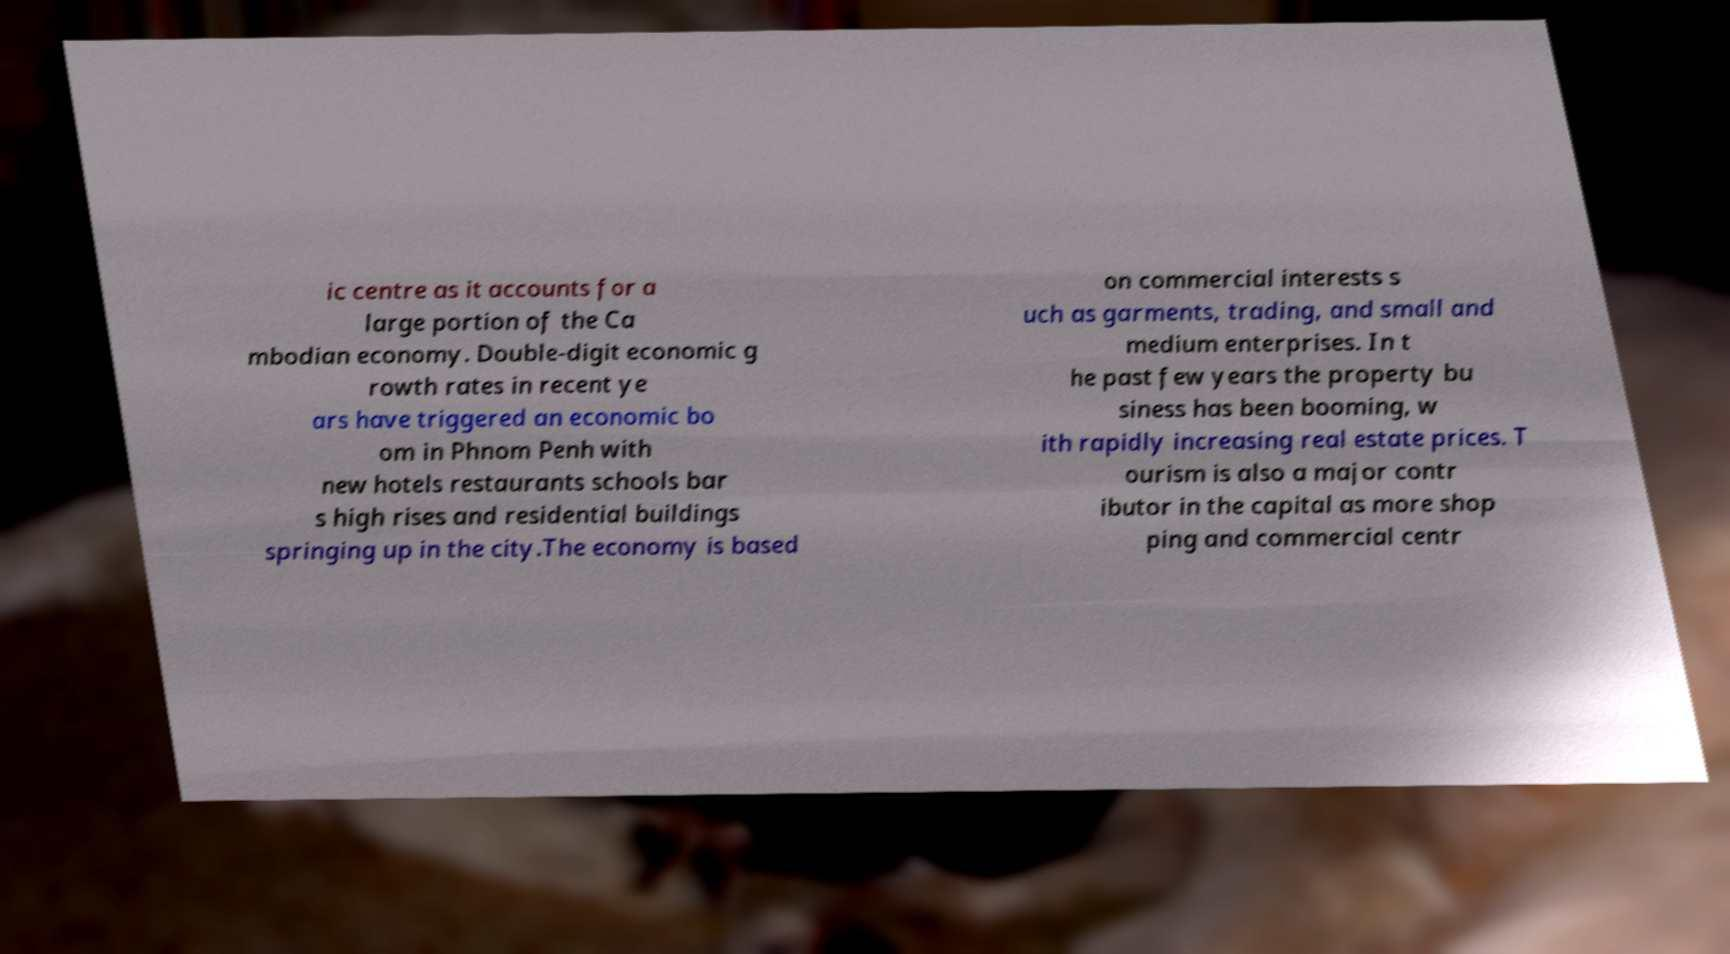Can you accurately transcribe the text from the provided image for me? ic centre as it accounts for a large portion of the Ca mbodian economy. Double-digit economic g rowth rates in recent ye ars have triggered an economic bo om in Phnom Penh with new hotels restaurants schools bar s high rises and residential buildings springing up in the city.The economy is based on commercial interests s uch as garments, trading, and small and medium enterprises. In t he past few years the property bu siness has been booming, w ith rapidly increasing real estate prices. T ourism is also a major contr ibutor in the capital as more shop ping and commercial centr 